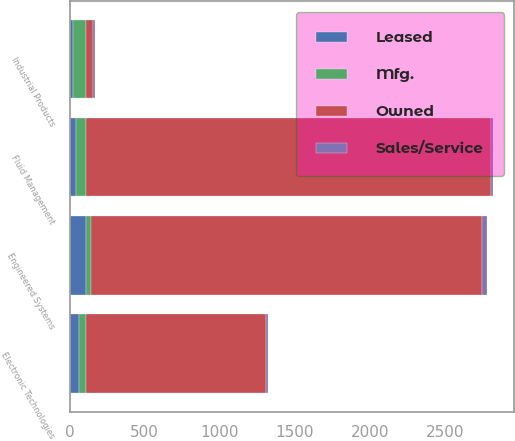Convert chart. <chart><loc_0><loc_0><loc_500><loc_500><stacked_bar_chart><ecel><fcel>Industrial Products<fcel>Engineered Systems<fcel>Fluid Management<fcel>Electronic Technologies<nl><fcel>Mfg.<fcel>82<fcel>36<fcel>67<fcel>51<nl><fcel>Sales/Service<fcel>11<fcel>35<fcel>13<fcel>10<nl><fcel>Leased<fcel>25<fcel>108<fcel>41<fcel>60<nl><fcel>Owned<fcel>51<fcel>2600<fcel>2700<fcel>1200<nl></chart> 